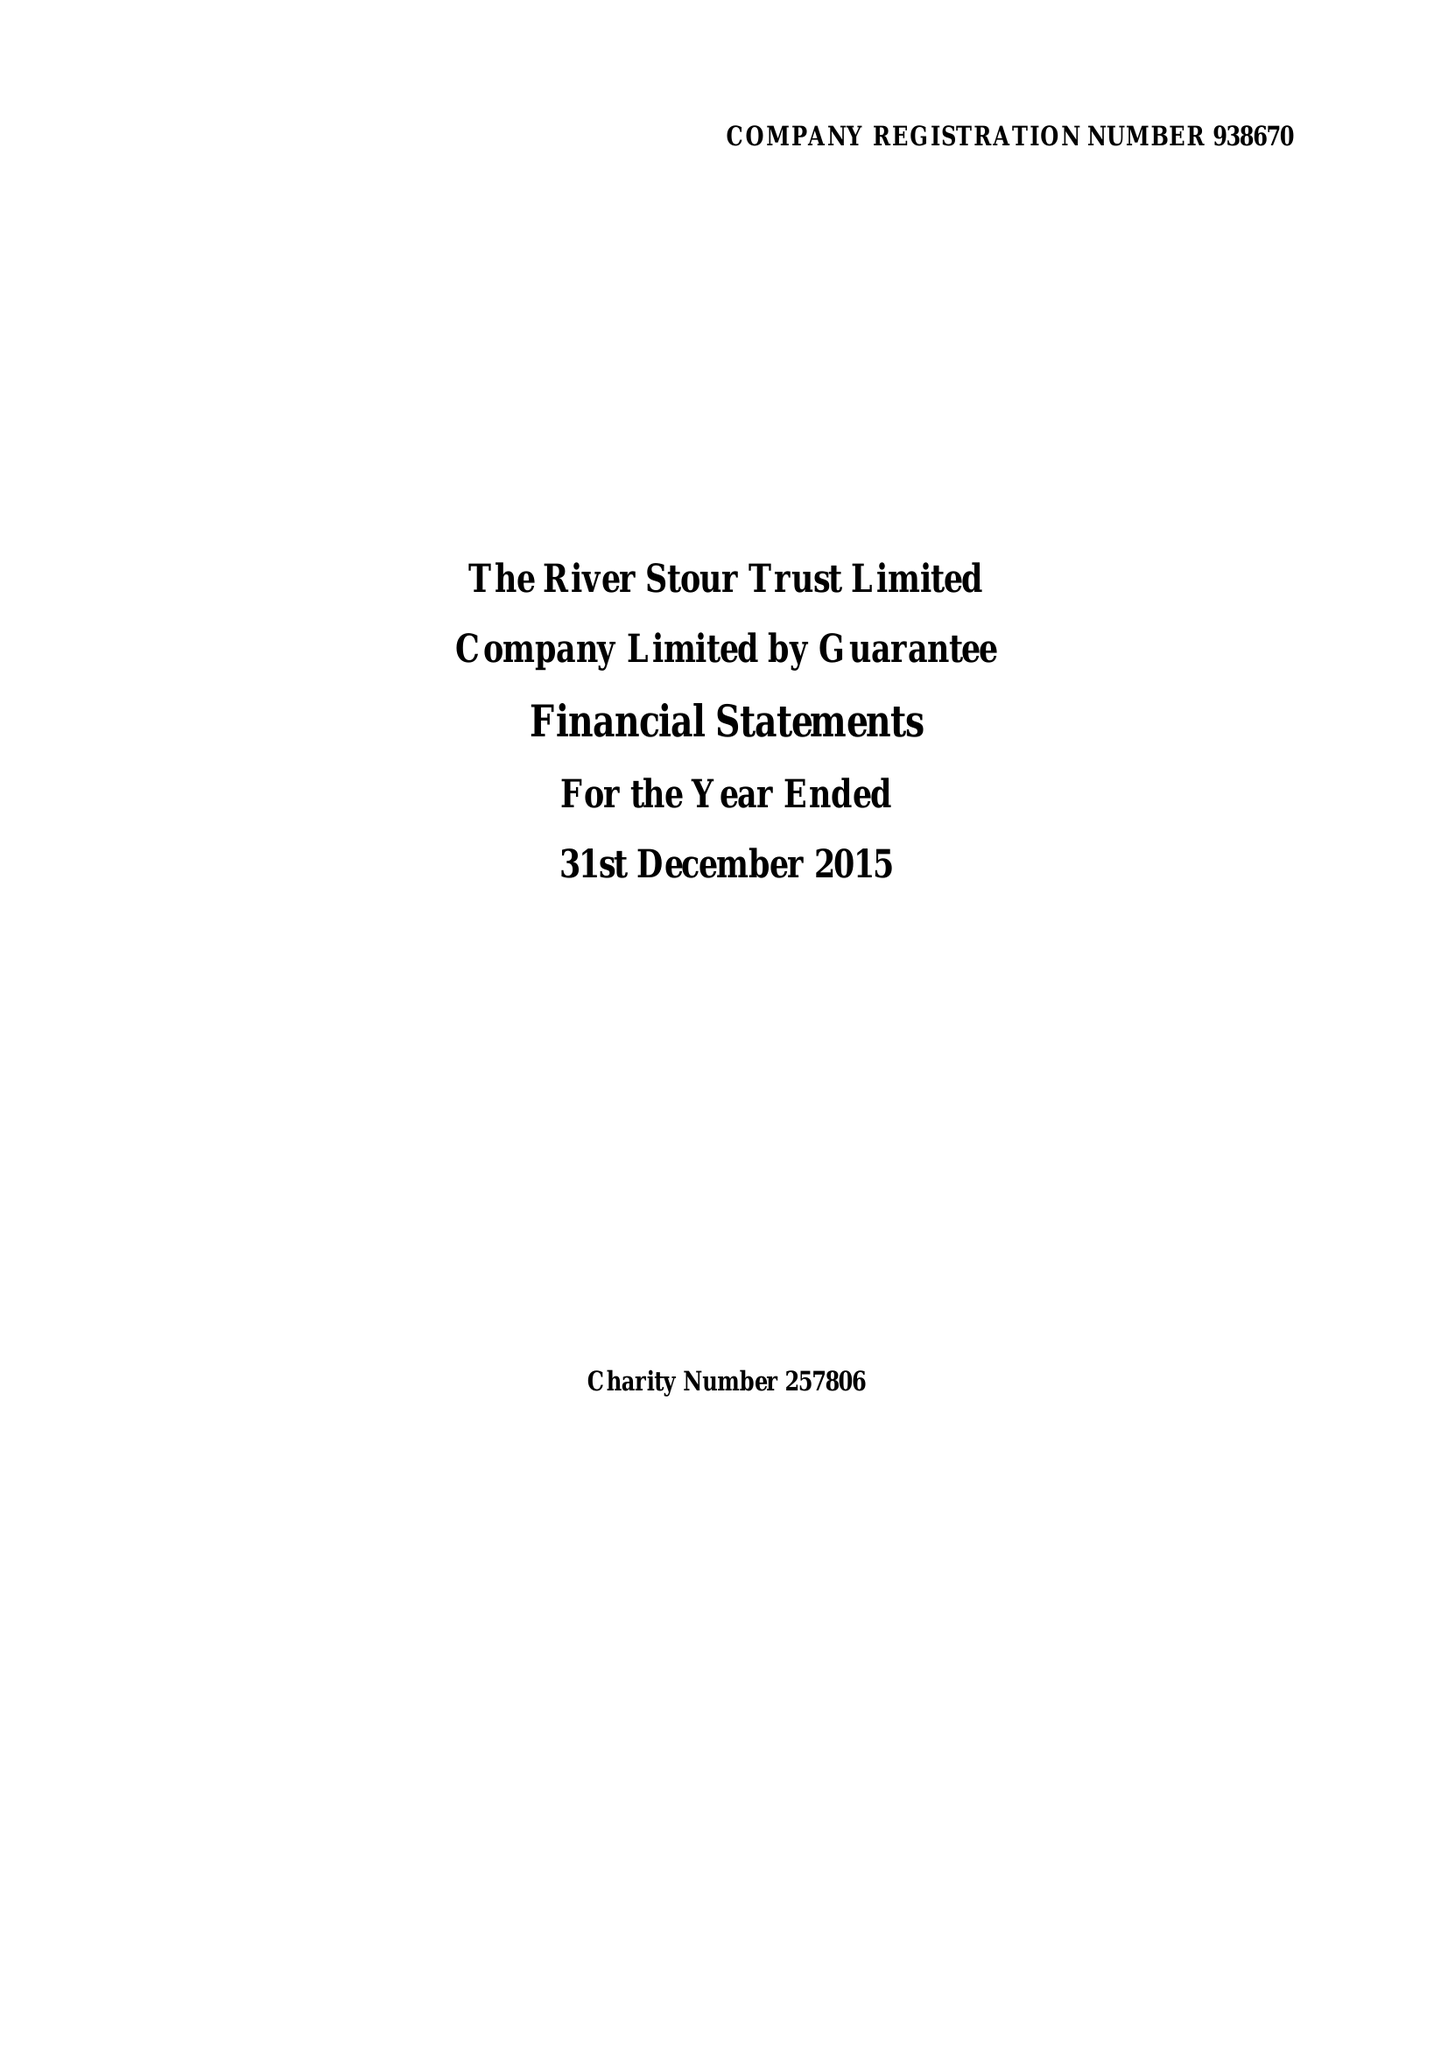What is the value for the charity_number?
Answer the question using a single word or phrase. 257806 